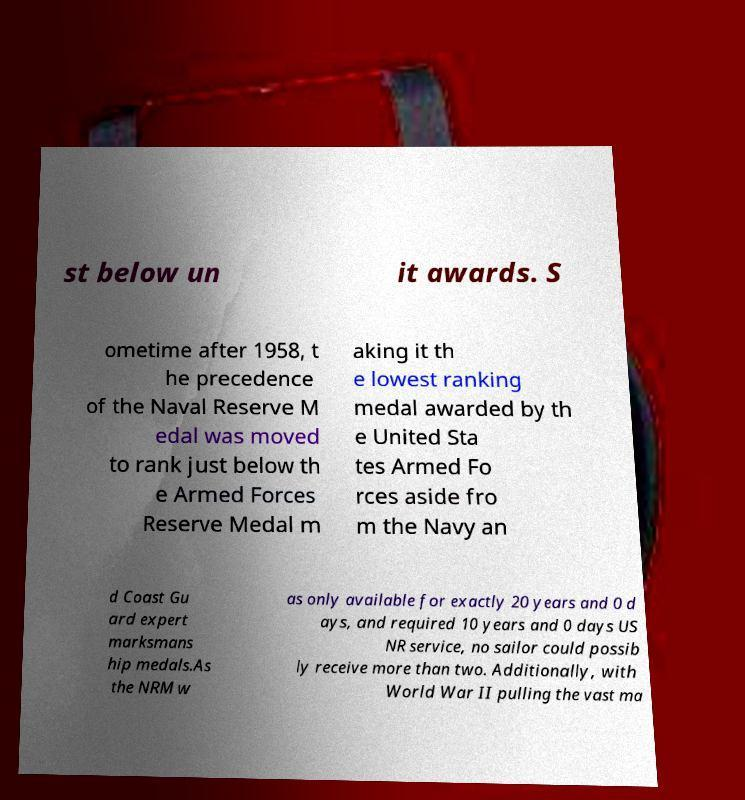Could you assist in decoding the text presented in this image and type it out clearly? st below un it awards. S ometime after 1958, t he precedence of the Naval Reserve M edal was moved to rank just below th e Armed Forces Reserve Medal m aking it th e lowest ranking medal awarded by th e United Sta tes Armed Fo rces aside fro m the Navy an d Coast Gu ard expert marksmans hip medals.As the NRM w as only available for exactly 20 years and 0 d ays, and required 10 years and 0 days US NR service, no sailor could possib ly receive more than two. Additionally, with World War II pulling the vast ma 